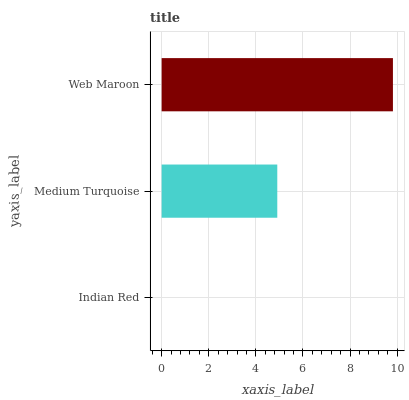Is Indian Red the minimum?
Answer yes or no. Yes. Is Web Maroon the maximum?
Answer yes or no. Yes. Is Medium Turquoise the minimum?
Answer yes or no. No. Is Medium Turquoise the maximum?
Answer yes or no. No. Is Medium Turquoise greater than Indian Red?
Answer yes or no. Yes. Is Indian Red less than Medium Turquoise?
Answer yes or no. Yes. Is Indian Red greater than Medium Turquoise?
Answer yes or no. No. Is Medium Turquoise less than Indian Red?
Answer yes or no. No. Is Medium Turquoise the high median?
Answer yes or no. Yes. Is Medium Turquoise the low median?
Answer yes or no. Yes. Is Web Maroon the high median?
Answer yes or no. No. Is Indian Red the low median?
Answer yes or no. No. 